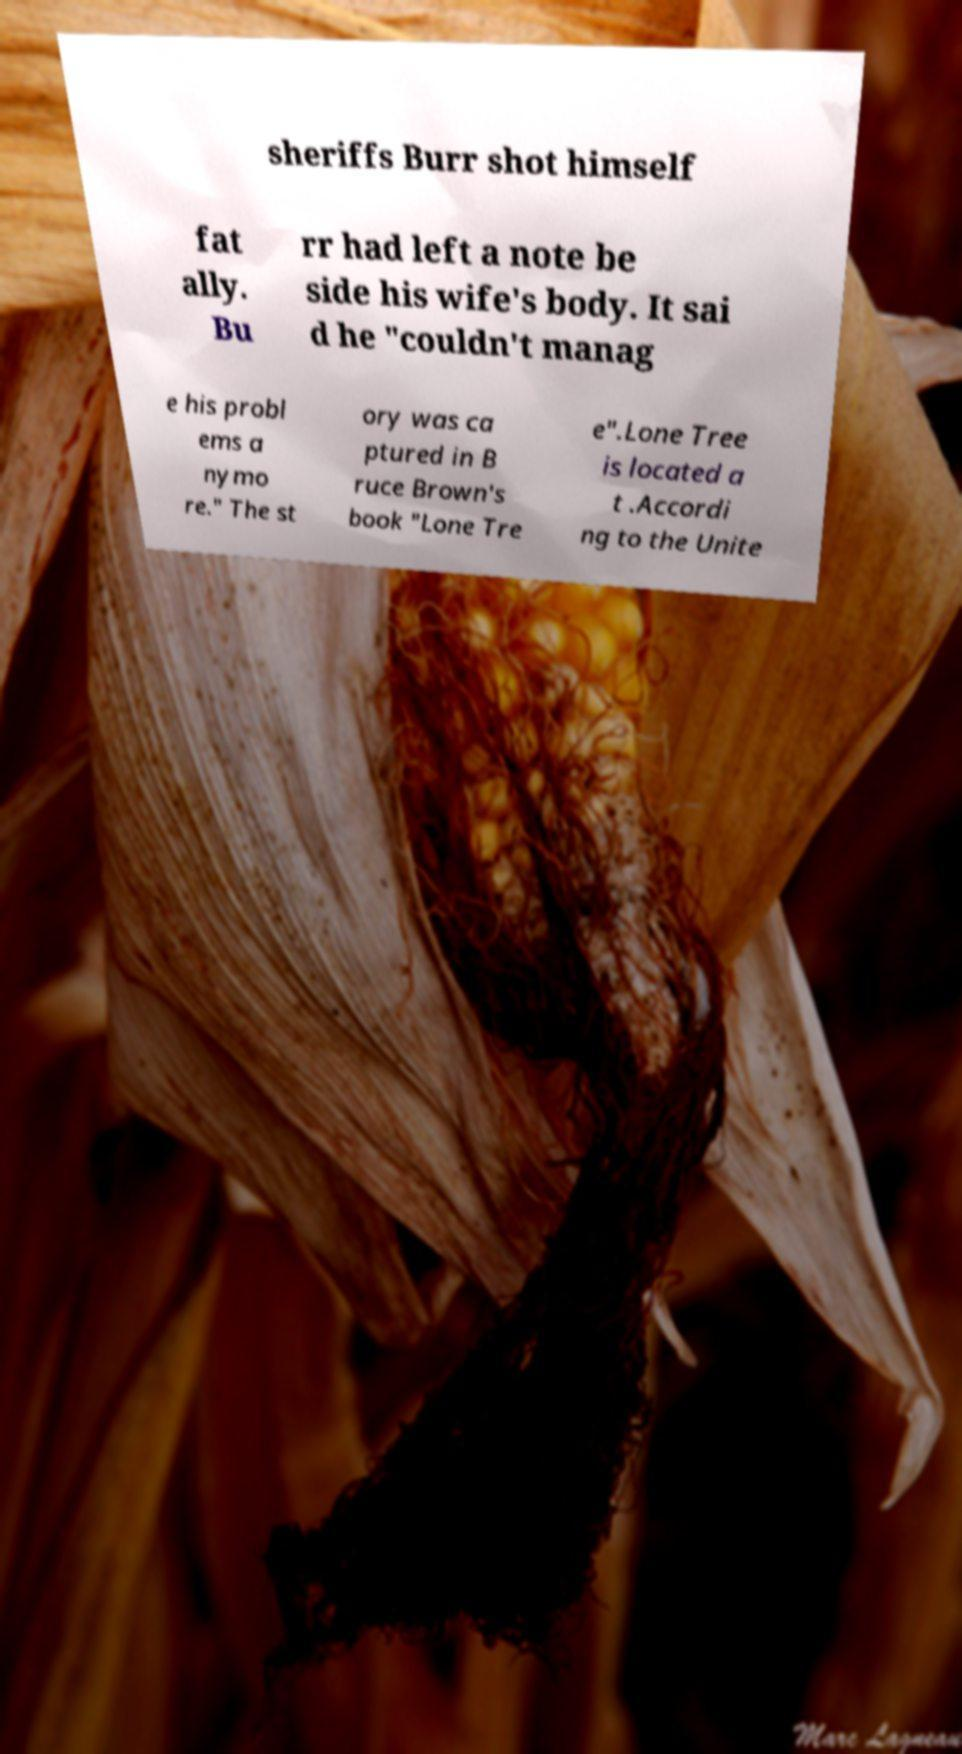Could you extract and type out the text from this image? sheriffs Burr shot himself fat ally. Bu rr had left a note be side his wife's body. It sai d he "couldn't manag e his probl ems a nymo re." The st ory was ca ptured in B ruce Brown's book "Lone Tre e".Lone Tree is located a t .Accordi ng to the Unite 